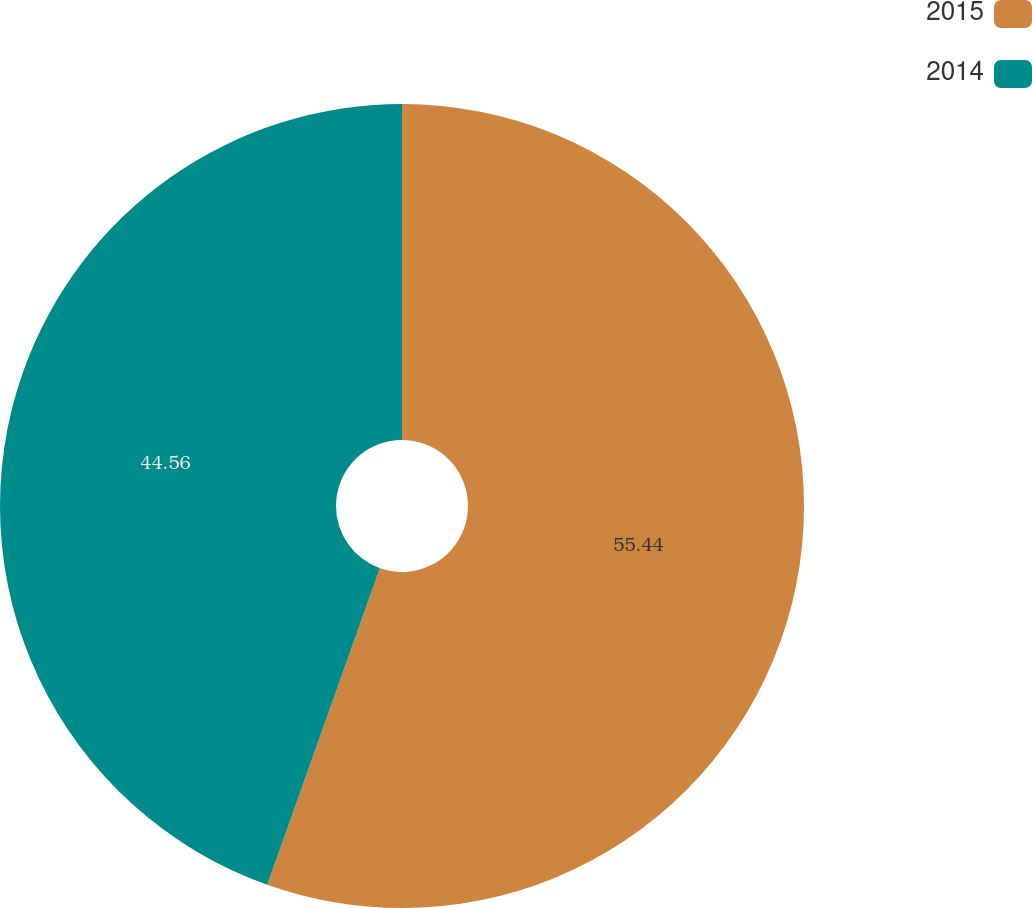<chart> <loc_0><loc_0><loc_500><loc_500><pie_chart><fcel>2015<fcel>2014<nl><fcel>55.44%<fcel>44.56%<nl></chart> 